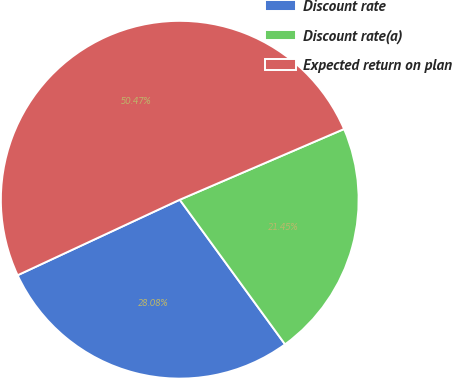Convert chart to OTSL. <chart><loc_0><loc_0><loc_500><loc_500><pie_chart><fcel>Discount rate<fcel>Discount rate(a)<fcel>Expected return on plan<nl><fcel>28.08%<fcel>21.45%<fcel>50.47%<nl></chart> 